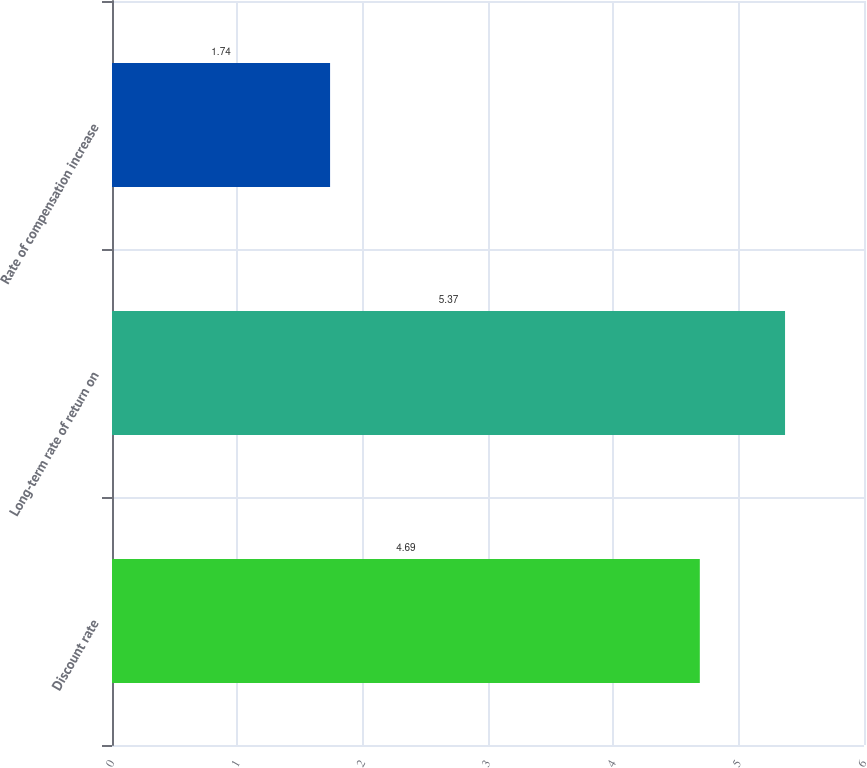Convert chart to OTSL. <chart><loc_0><loc_0><loc_500><loc_500><bar_chart><fcel>Discount rate<fcel>Long-term rate of return on<fcel>Rate of compensation increase<nl><fcel>4.69<fcel>5.37<fcel>1.74<nl></chart> 